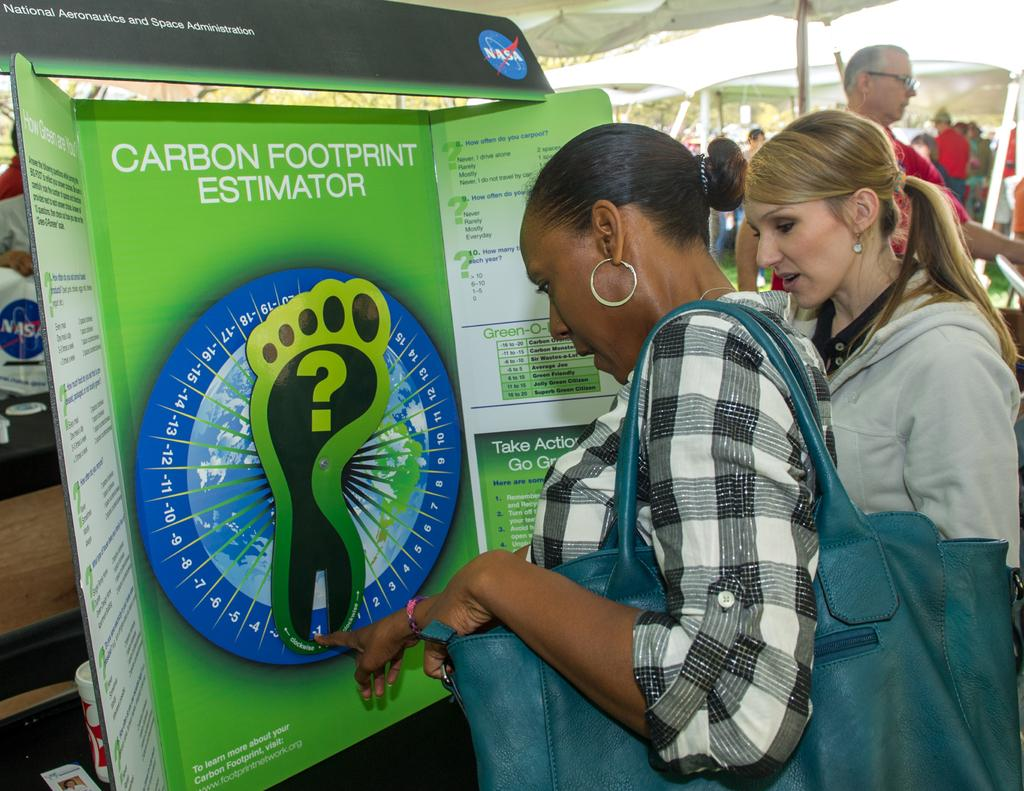Who or what can be seen in the image? There are people in the image. What objects are present in the image? There are boards, a tent, a cup on a platform, and a card on the platform. Can you describe the setting of the image? In the background of the image, there are people and tents. What is the purpose of the platform in the image? The platform holds a cup and a card. What type of music can be heard playing in the background of the image? There is no music present in the image, as it only shows people, boards, a tent, a cup, and a card. 